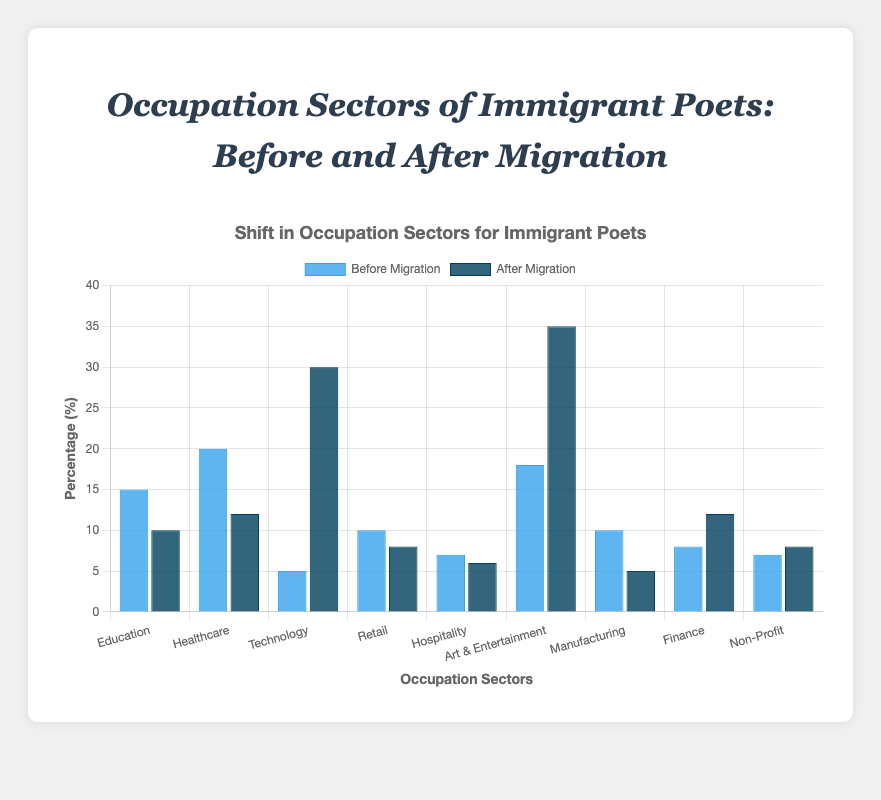Which occupation sector saw the highest increase in the number of immigrant poets after migration? The "Art & Entertainment" sector increased from 18 before migration to 35 after migration, which is the highest gain among all sectors.
Answer: Art & Entertainment Which occupation sector had the largest decrease in the number of immigrant poets after migration? Healthcare decreased from 20 before migration to 12 after migration, which is the largest decrease.
Answer: Healthcare How many more poets work in the Technology sector after migration compared to before? After migration, there are 30 poets in Technology compared to 5 before, making the difference 30 - 5 = 25.
Answer: 25 What's the sum of poets in the Education and Healthcare sectors after migration? Education has 10 poets, and Healthcare has 12 poets after migration, so the sum is 10 + 12 = 22.
Answer: 22 What is the difference in the number of poets in the Retail sector before and after migration? The Retail sector had 10 poets before migration and 8 after, so the difference is 10 - 8 = 2.
Answer: 2 In which sectors did the number of poets remain almost the same before and after migration? The Hospitality sector had 7 poets before and 6 after, while the Non-Profit sector had 7 poets before and 8 after. Both sectors saw only a slight change.
Answer: Hospitality and Non-Profit Which occupation sector had an equal number of poets to Finance before migration? Manufacturing had an equal number of poets (10) to Finance after migration (12), leading to a difference of 2 poets while both sectors had an equal baseline count initially.
Answer: Manufacturing What is the percentage increase in poets in the Technology sector after migration? The Technology sector increased from 5 to 30 poets. The percentage increase is ((30 - 5) / 5) * 100 = 500%.
Answer: 500% What is the combined total of poets in the Art & Entertainment and Finance sectors after migration? Art & Entertainment has 35 poets and Finance has 12 poets after migration, so the combined total is 35 + 12 = 47.
Answer: 47 How many sectors saw a decrease in the number of poets after migration? Education, Healthcare, Retail, Hospitality, and Manufacturing sectors saw decreases in the number of poets after migration, totaling 5 sectors.
Answer: 5 sectors 